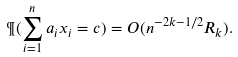Convert formula to latex. <formula><loc_0><loc_0><loc_500><loc_500>\P ( \sum _ { i = 1 } ^ { n } a _ { i } x _ { i } = c ) = O ( n ^ { - 2 k - 1 / 2 } R _ { k } ) .</formula> 